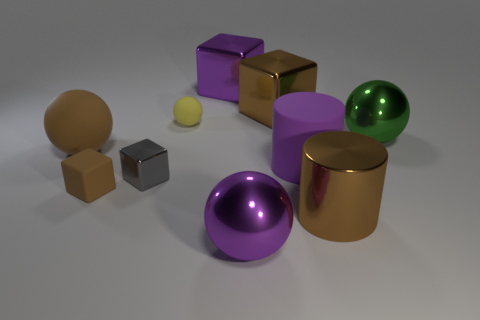Subtract 1 blocks. How many blocks are left? 3 Subtract all spheres. How many objects are left? 6 Add 3 big green spheres. How many big green spheres are left? 4 Add 5 big matte things. How many big matte things exist? 7 Subtract 0 blue blocks. How many objects are left? 10 Subtract all large brown metallic cylinders. Subtract all big purple metal spheres. How many objects are left? 8 